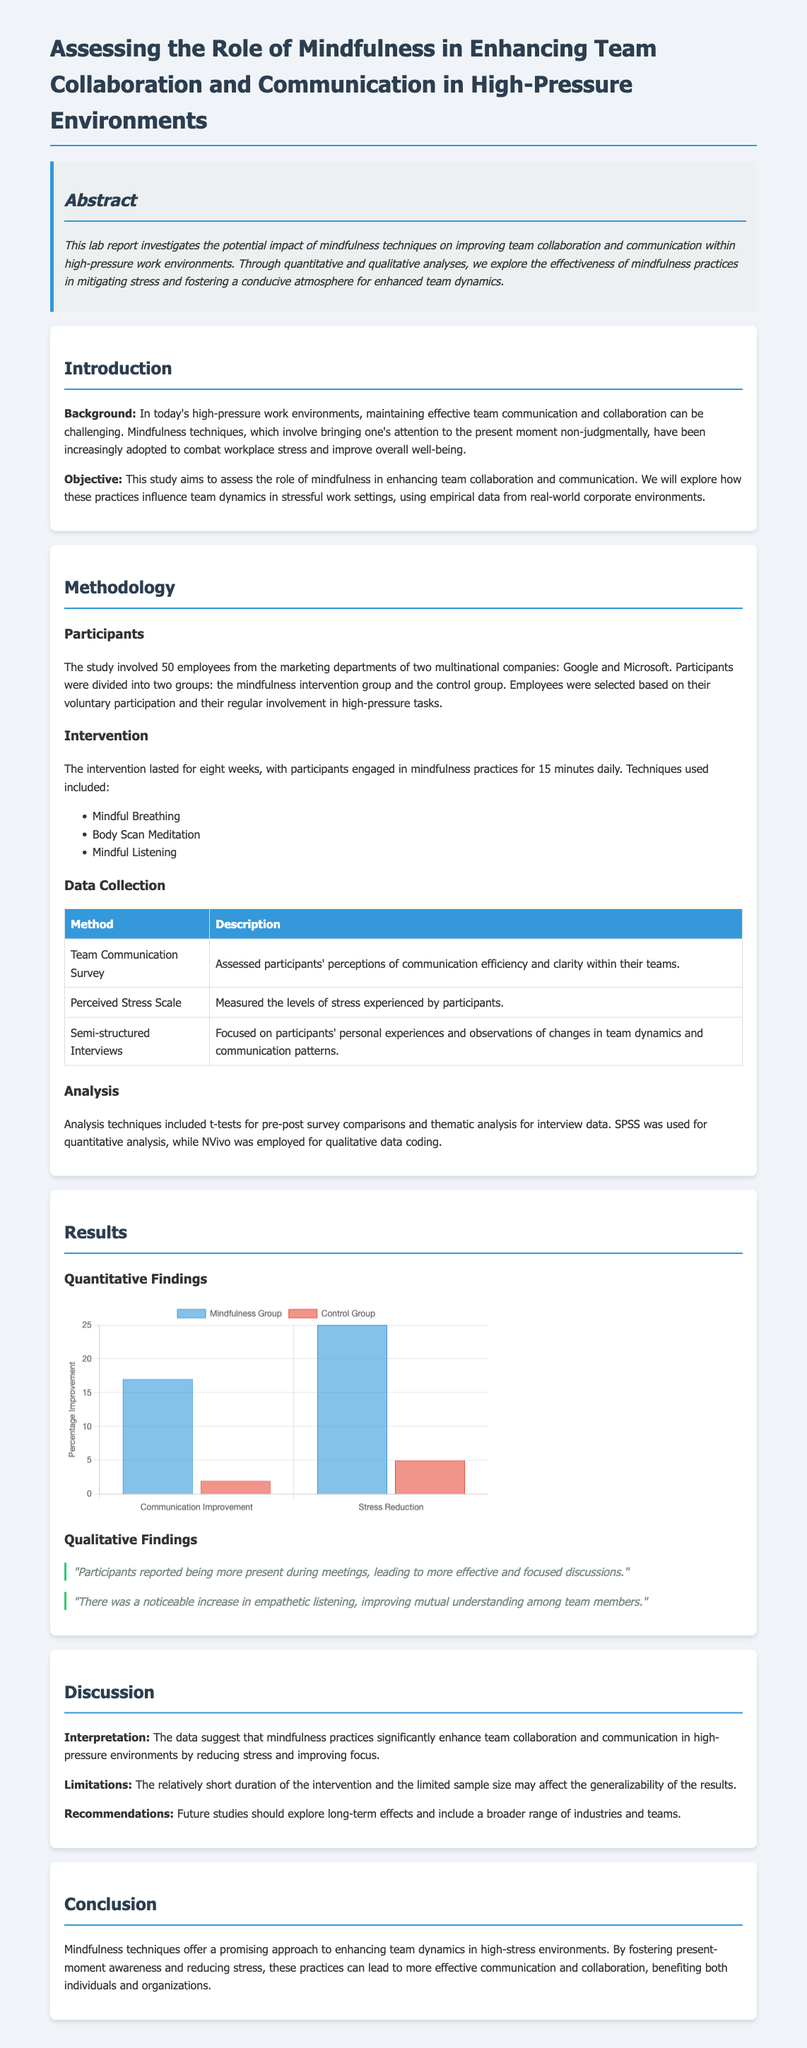What is the main objective of the study? The objective stated in the document is to assess the role of mindfulness in enhancing team collaboration and communication.
Answer: Enhance team collaboration and communication How long did the mindfulness intervention last? The document specifies that the intervention lasted for eight weeks.
Answer: Eight weeks What mindfulness technique involved focusing on breath? The document lists mindful breathing as one of the techniques used.
Answer: Mindful Breathing How many employees participated in the study? The participant count detailed in the document is 50 employees.
Answer: 50 employees What software was used for quantitative analysis? The document mentions that SPSS was used for quantitative analysis.
Answer: SPSS What was a notable qualitative finding from participants? Participants noted an increase in empathetic listening among team members.
Answer: Increase in empathetic listening What does the abstract highlight as a key aspect of the study? The abstract emphasizes the potential impact of mindfulness techniques in improving team collaboration and communication.
Answer: Improving team collaboration and communication What is a recommendation for future studies mentioned in the report? The document recommends exploring long-term effects in future studies.
Answer: Explore long-term effects 